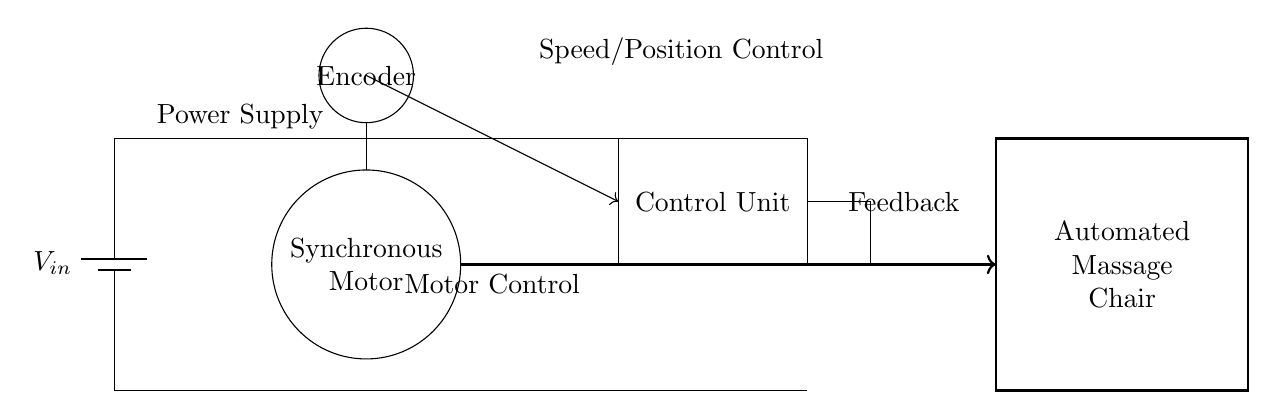What is the main component represented in the circle? The main component is labeled as "Synchronous Motor," which identifies its function in the circuit.
Answer: Synchronous Motor What connects the power supply to the control unit? A direct line connects the power supply, marked as V-in, to the control unit, indicating the flow of electricity necessary for operation.
Answer: A direct line What is the role of the encoder in this circuit? The encoder's role is to provide speed and position feedback to the control unit, which helps in fine-tuning the operation of the synchronous motor.
Answer: Feedback How many connections are leading into the synchronous motor? There is one connection leading into the synchronous motor from the control unit, indicating a direct input for control signals.
Answer: One connection Which component provides feedback to the control unit? The feedback is provided by the encoder, which sends information back to the control unit to assist in controlling the motor’s speed and position accurately.
Answer: Encoder What does the rectangle labeled "Control Unit" represent? The control unit is responsible for managing the operation of the synchronous motor based on inputs from the encoder and the power supply.
Answer: Control Unit How is the automated massage chair connected to the synchronous motor? A thick arrow indicates a direct connection from the synchronous motor to the automated massage chair, representing the output motion control.
Answer: Direct connection 